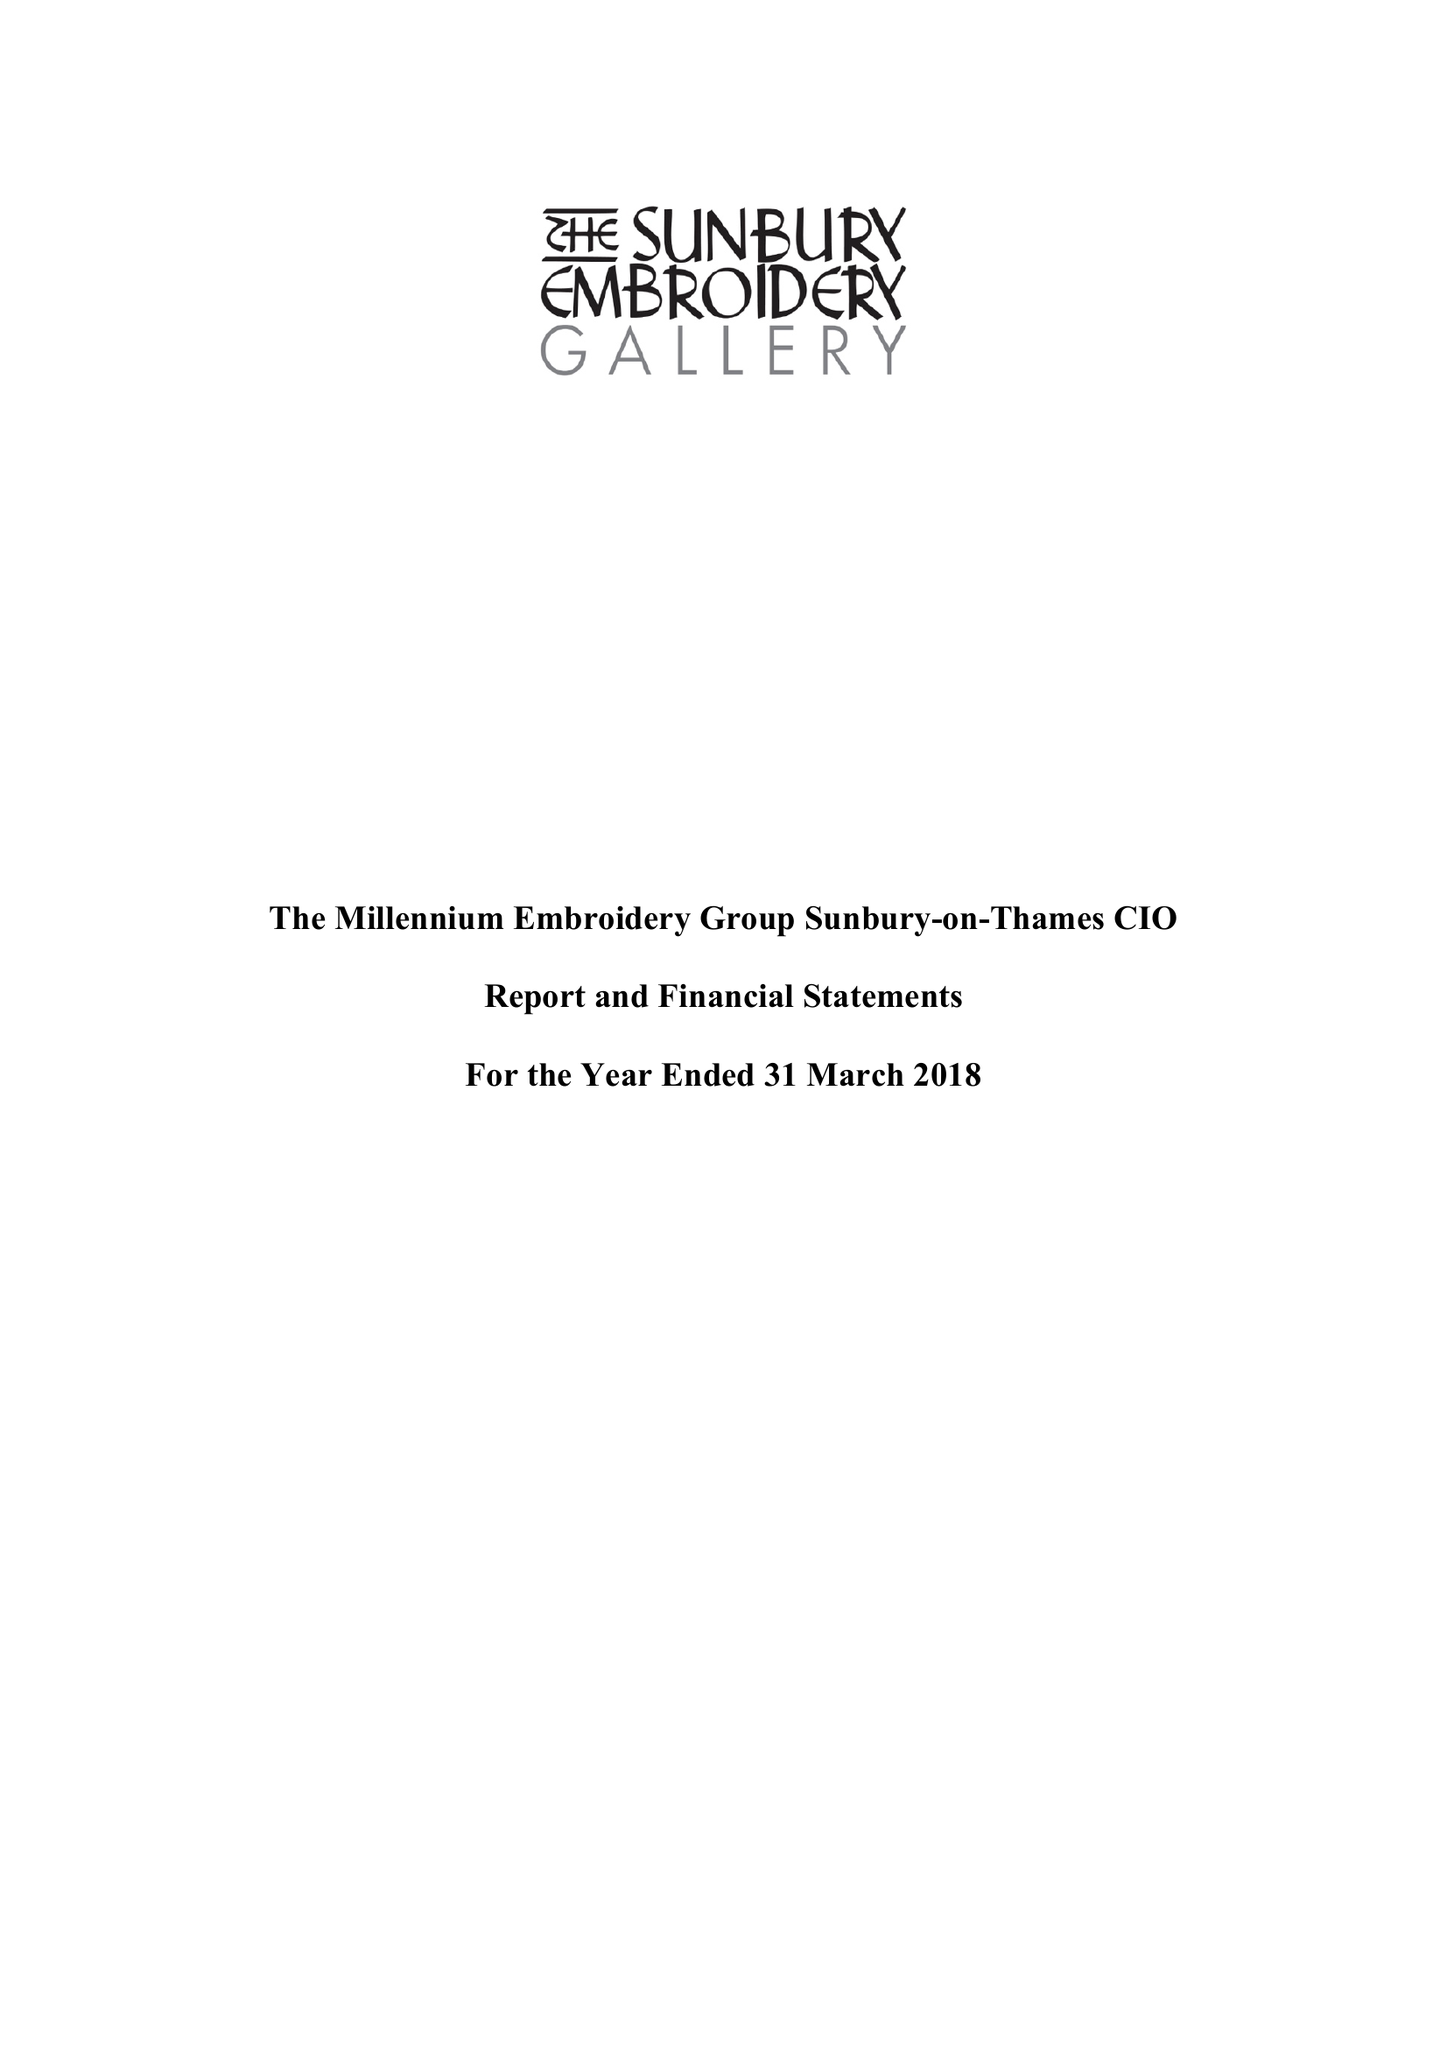What is the value for the address__postcode?
Answer the question using a single word or phrase. TW16 6AB 